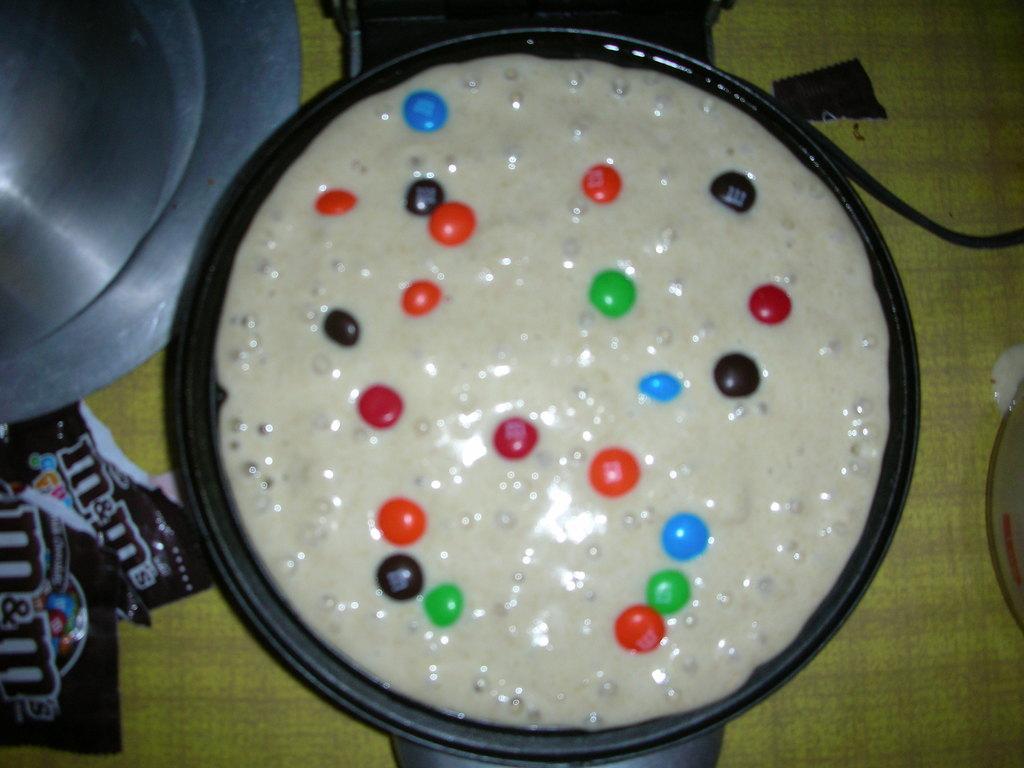How would you summarize this image in a sentence or two? In this image I can see in the middle it looks like the food in a pan, on the left side there are plastic covers. 